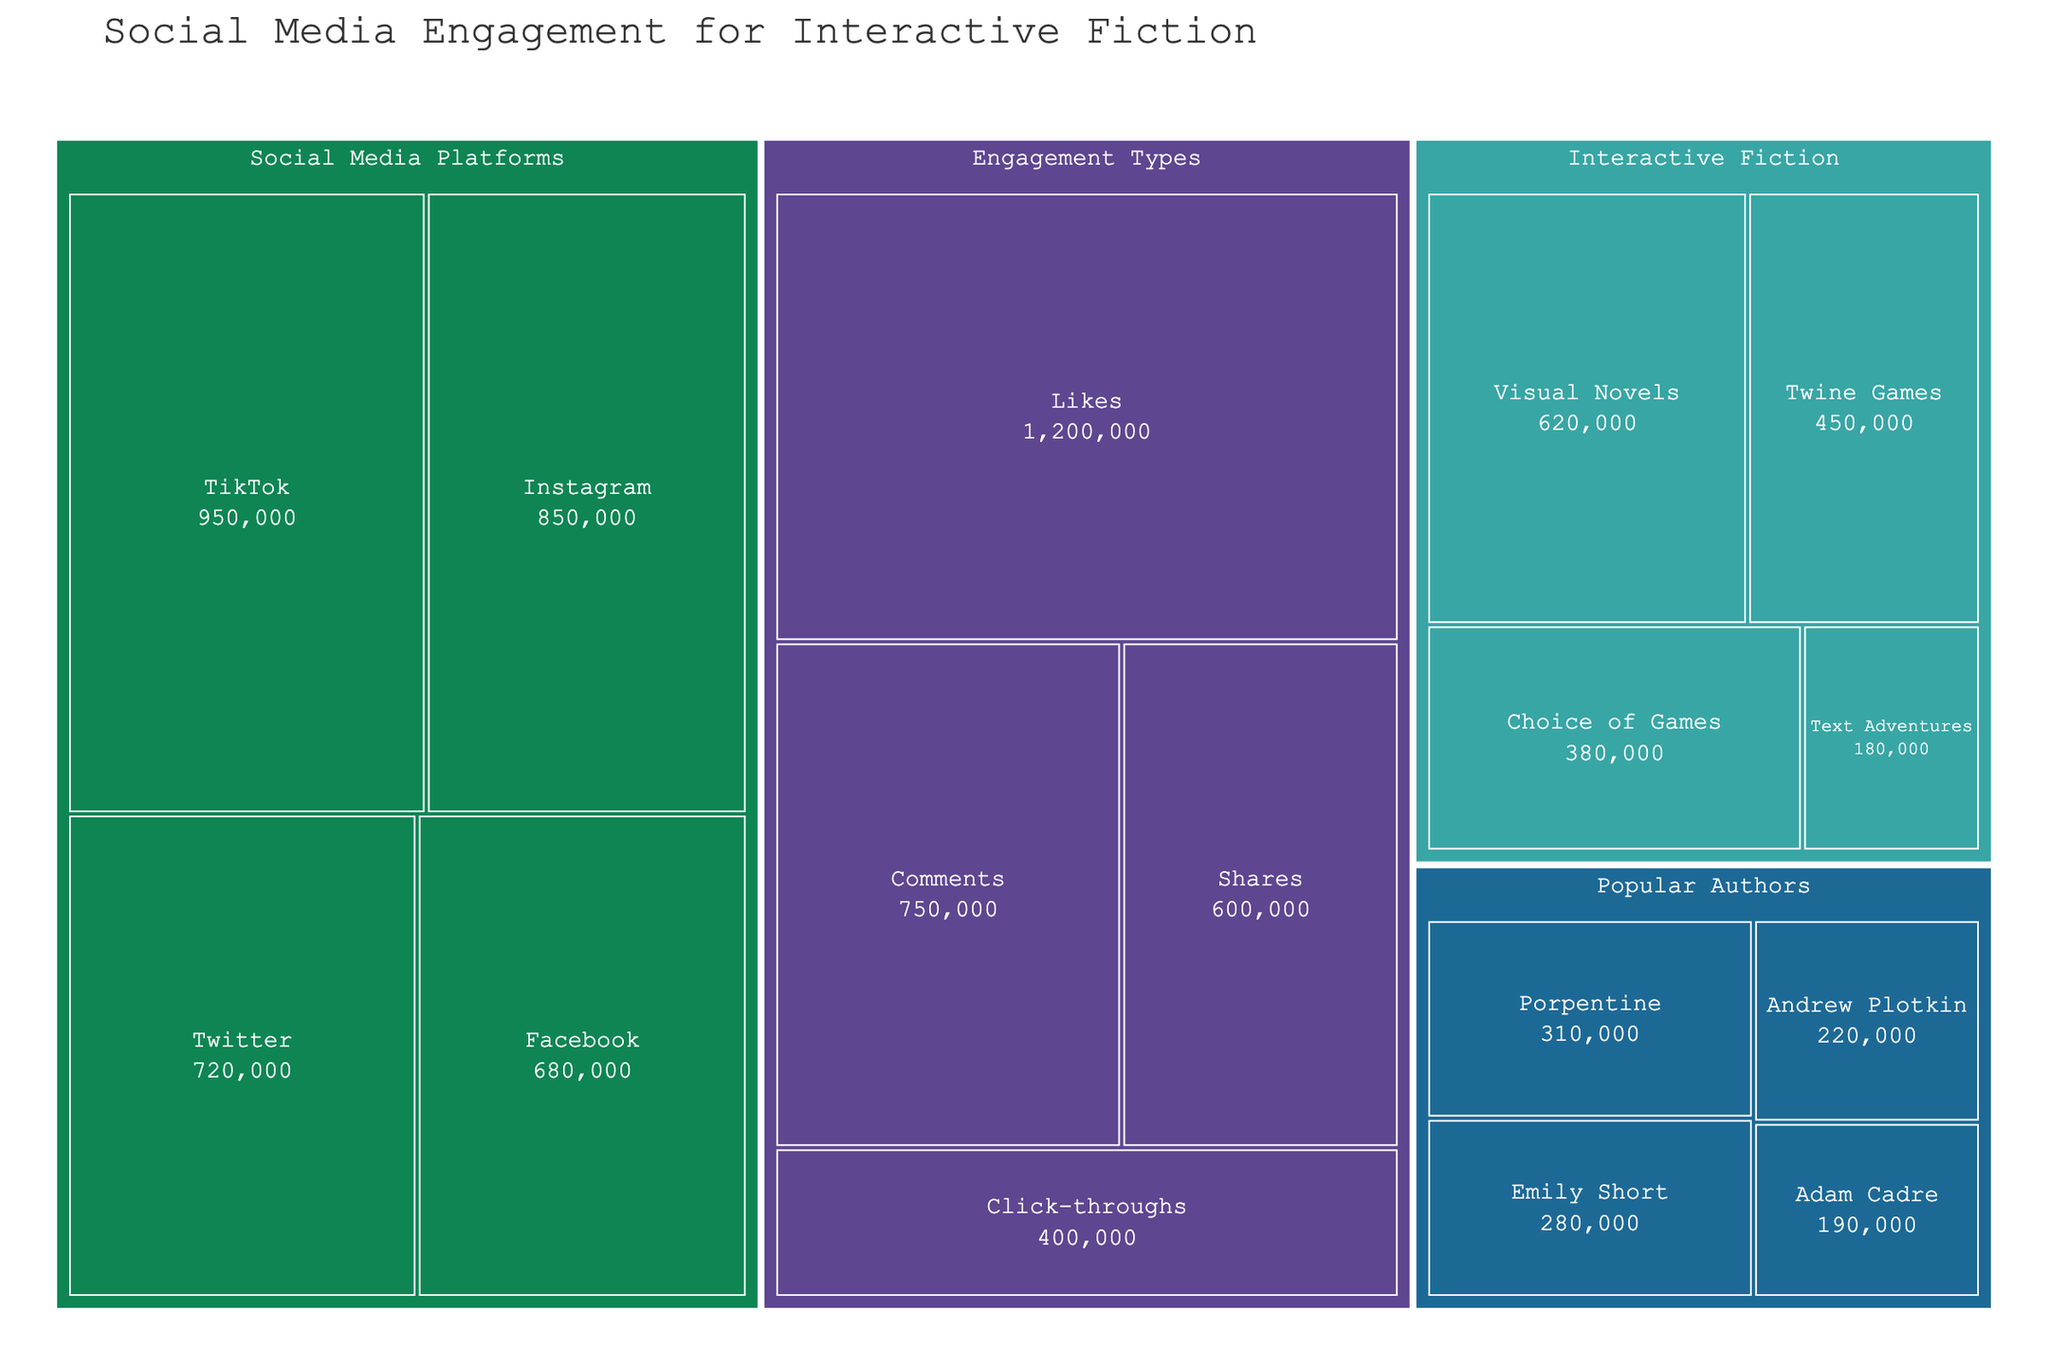Which category has the highest overall social media engagement? To determine this, we need to compare the total engagement values for each category. The categories are "Interactive Fiction," "Social Media Platforms," "Engagement Types," and "Popular Authors." Summing up each category, we find: - Interactive Fiction: 1,630,000 - Social Media Platforms: 3,200,000 - Engagement Types: 3,050,000 - Popular Authors: 1,000,000. "Social Media Platforms" has the highest total engagement.
Answer: Social Media Platforms Which subcategory in "Interactive Fiction" has the lowest engagement? We look at the engagement values for the subcategories within "Interactive Fiction," which are "Twine Games" (450,000), "Choice of Games" (380,000), "Visual Novels" (620,000), and "Text Adventures" (180,000). "Text Adventures" has the lowest engagement.
Answer: Text Adventures How much more engagement does "TikTok" have compared to "Twitter"? We compare the engagement values for "TikTok" (950,000) and "Twitter" (720,000). The difference is 950,000 - 720,000. The additional engagement is 230,000.
Answer: 230,000 Which engagement type has the least engagement? We look at the engagement types and their values: "Likes" (1,200,000), "Comments" (750,000), "Shares" (600,000), and "Click-throughs" (400,000). "Click-throughs" has the least engagement.
Answer: Click-throughs What is the combined engagement of "Instagram" and "Facebook"? We sum the engagement values of "Instagram" (850,000) and "Facebook" (680,000). The total is 850,000 + 680,000.
Answer: 1,530,000 Who is the most popular author based on engagement? We compare the engagement values of the authors: Emily Short (280,000), Andrew Plotkin (220,000), Porpentine (310,000), and Adam Cadre (190,000). Porpentine has the highest engagement.
Answer: Porpentine What is the difference between the highest and lowest subcategory engagements in "Interactive Fiction"? The highest subcategory engagement in "Interactive Fiction" is "Visual Novels" (620,000), and the lowest is "Text Adventures" (180,000). The difference is 620,000 - 180,000.
Answer: 440,000 How many categories are represented in the treemap? We count the unique main categories in the dataset: "Interactive Fiction," "Social Media Platforms," "Engagement Types," and "Popular Authors." There are four categories.
Answer: 4 Which has higher engagement: "Visual Novels" or "Comments"? "Visual Novels" has an engagement of 620,000 and "Comments" has an engagement of 750,000. "Comments" has higher engagement.
Answer: Comments 